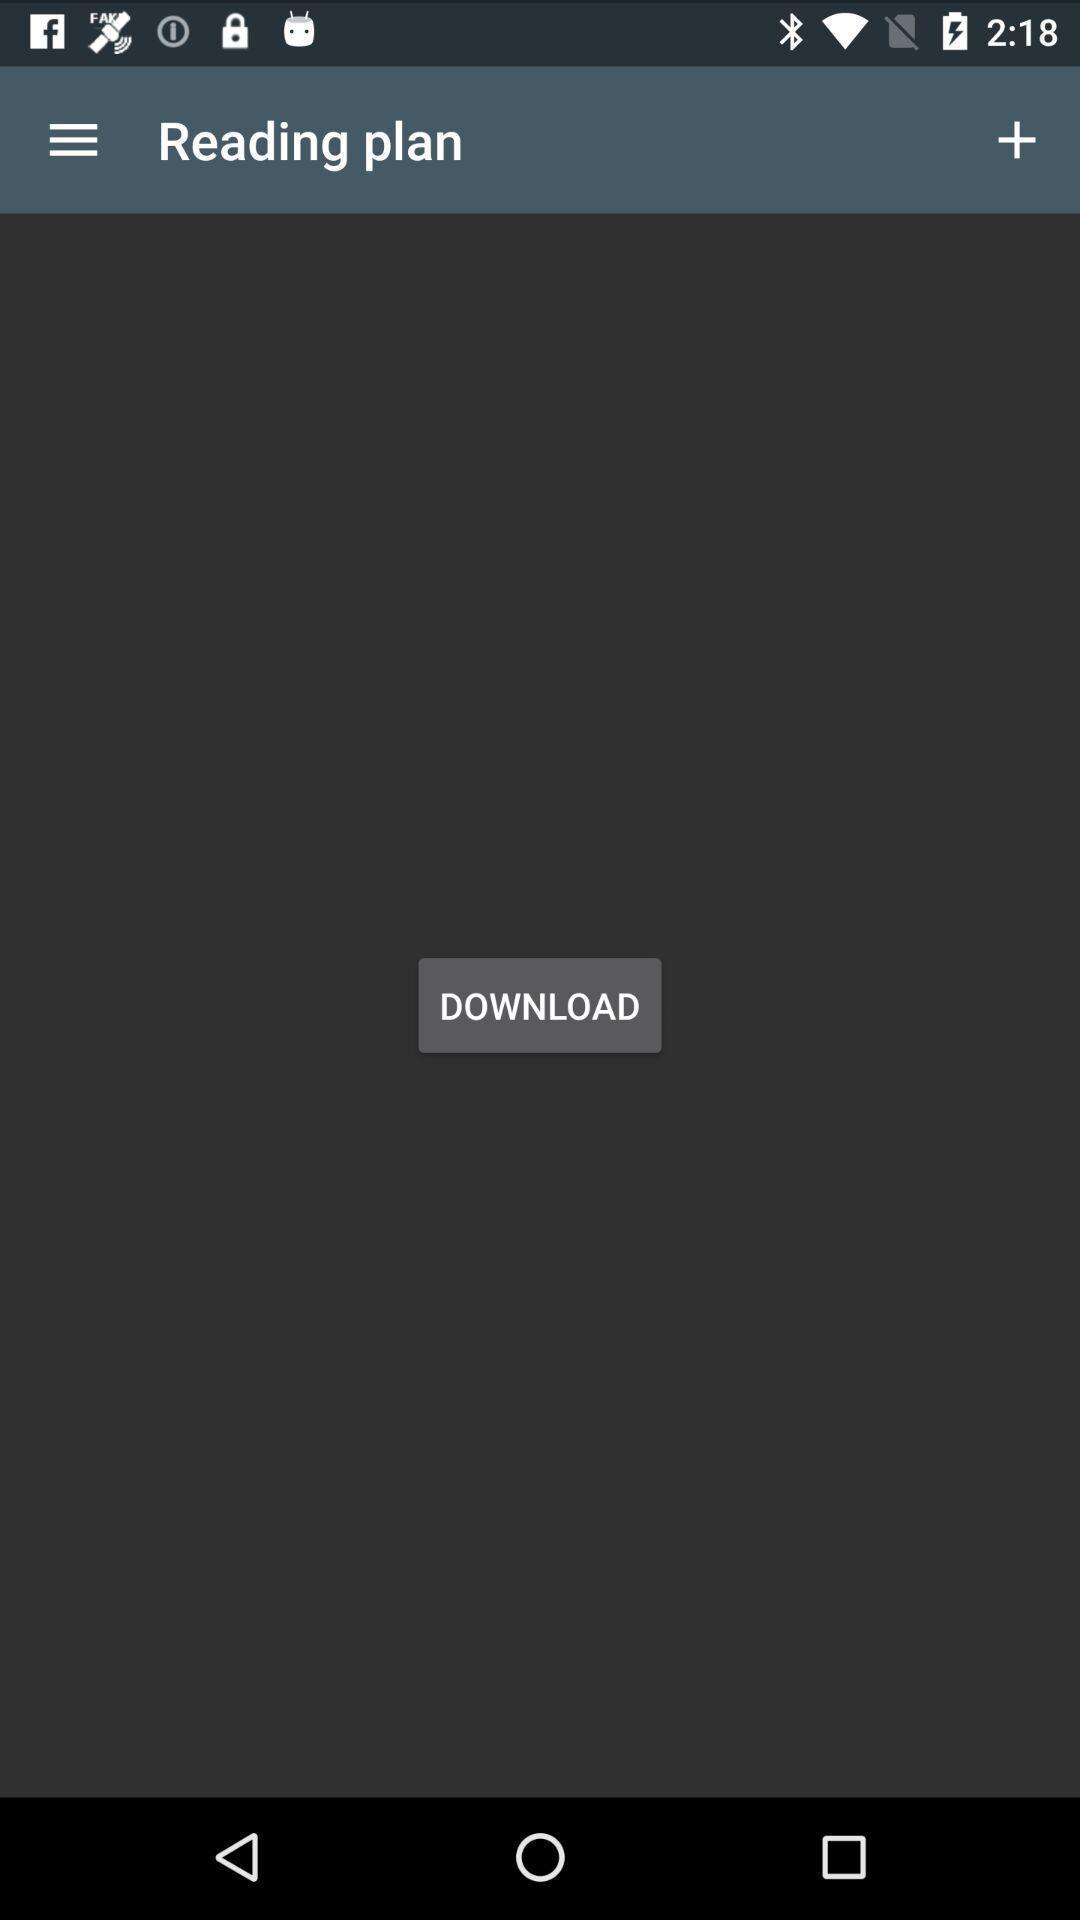Describe the key features of this screenshot. Screen displaying the reading plan page. 